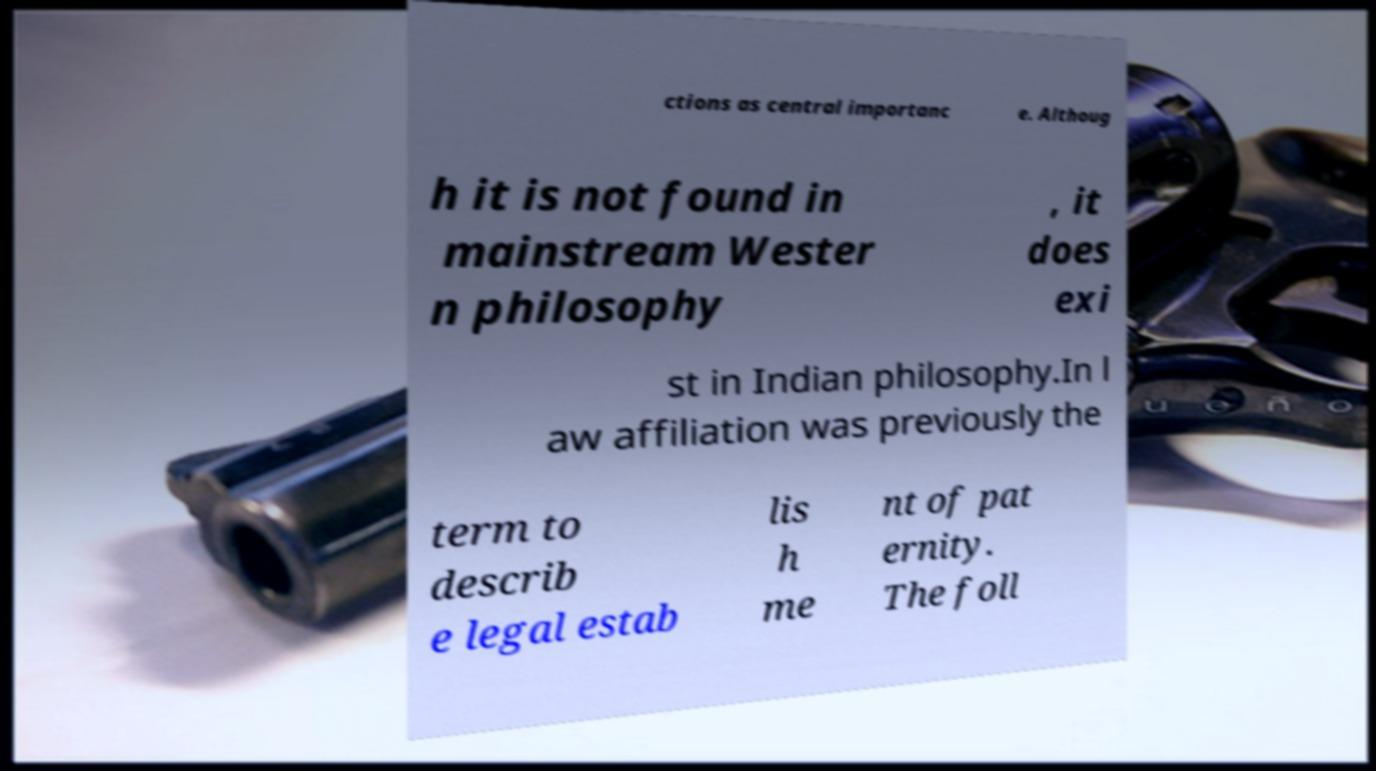Can you accurately transcribe the text from the provided image for me? ctions as central importanc e. Althoug h it is not found in mainstream Wester n philosophy , it does exi st in Indian philosophy.In l aw affiliation was previously the term to describ e legal estab lis h me nt of pat ernity. The foll 